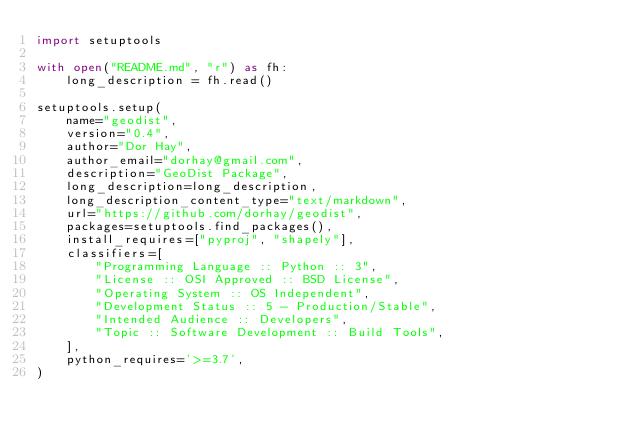<code> <loc_0><loc_0><loc_500><loc_500><_Python_>import setuptools

with open("README.md", "r") as fh:
    long_description = fh.read()

setuptools.setup(
    name="geodist",
    version="0.4",
    author="Dor Hay",
    author_email="dorhay@gmail.com",
    description="GeoDist Package",
    long_description=long_description,
    long_description_content_type="text/markdown",
    url="https://github.com/dorhay/geodist",
    packages=setuptools.find_packages(),
    install_requires=["pyproj", "shapely"],
    classifiers=[
        "Programming Language :: Python :: 3",
        "License :: OSI Approved :: BSD License",
        "Operating System :: OS Independent",
        "Development Status :: 5 - Production/Stable",
        "Intended Audience :: Developers",
        "Topic :: Software Development :: Build Tools",
    ],
    python_requires='>=3.7',
)
</code> 